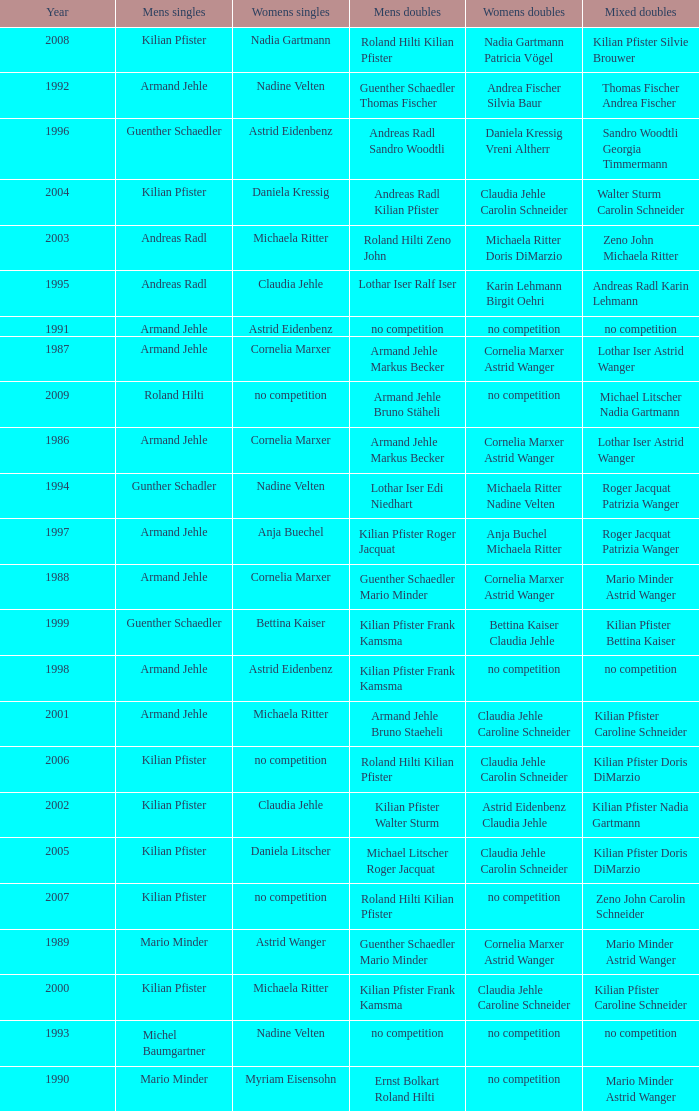In 2004, where the womens singles is daniela kressig who is the mens singles Kilian Pfister. 